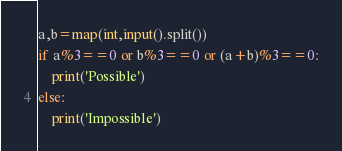<code> <loc_0><loc_0><loc_500><loc_500><_Python_>a,b=map(int,input().split())
if a%3==0 or b%3==0 or (a+b)%3==0:
    print('Possible')
else:
    print('Impossible')</code> 